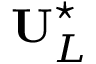<formula> <loc_0><loc_0><loc_500><loc_500>U _ { L } ^ { ^ { * } }</formula> 